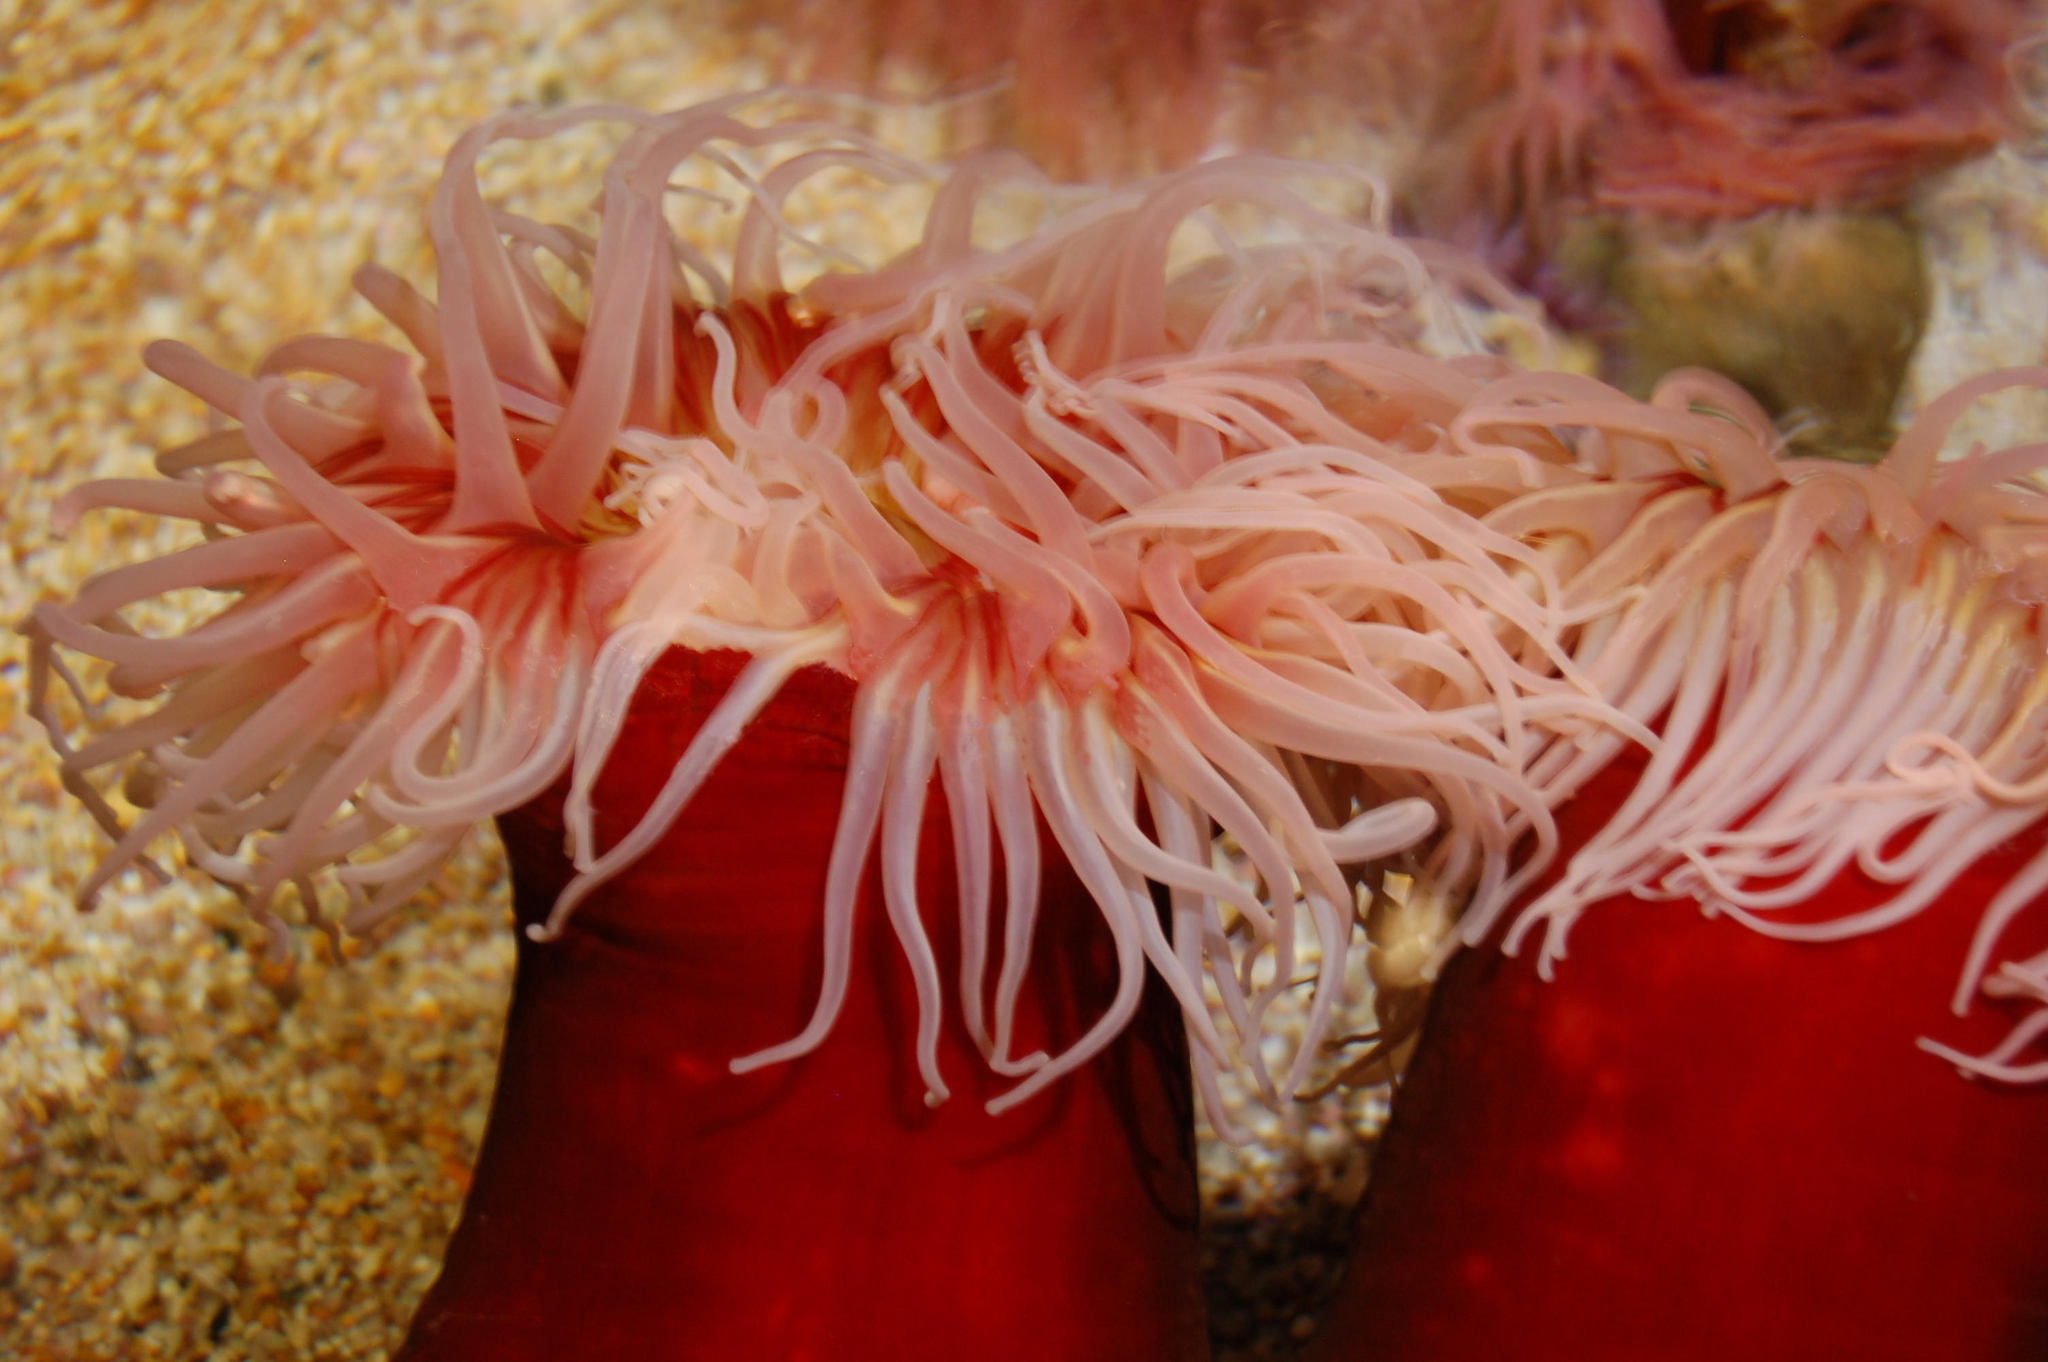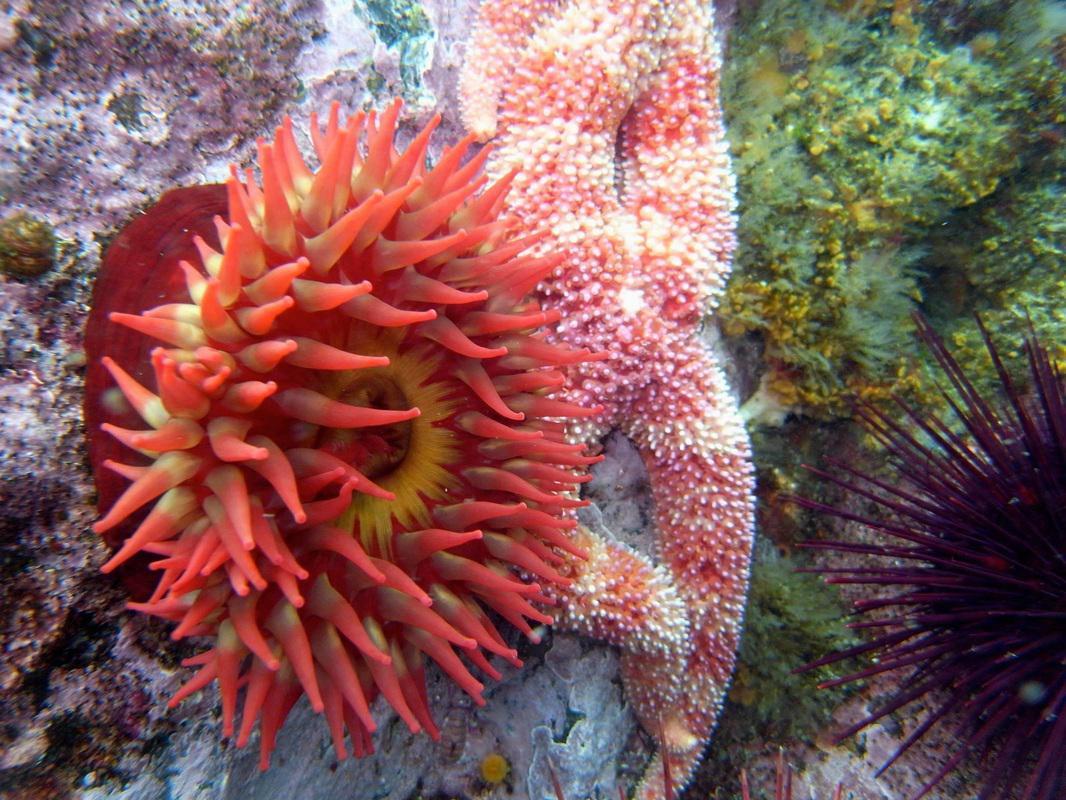The first image is the image on the left, the second image is the image on the right. Examine the images to the left and right. Is the description "there are two anemones in one of the images" accurate? Answer yes or no. Yes. The first image is the image on the left, the second image is the image on the right. Analyze the images presented: Is the assertion "An image includes an anemone with rich orange-red tendrils." valid? Answer yes or no. Yes. 